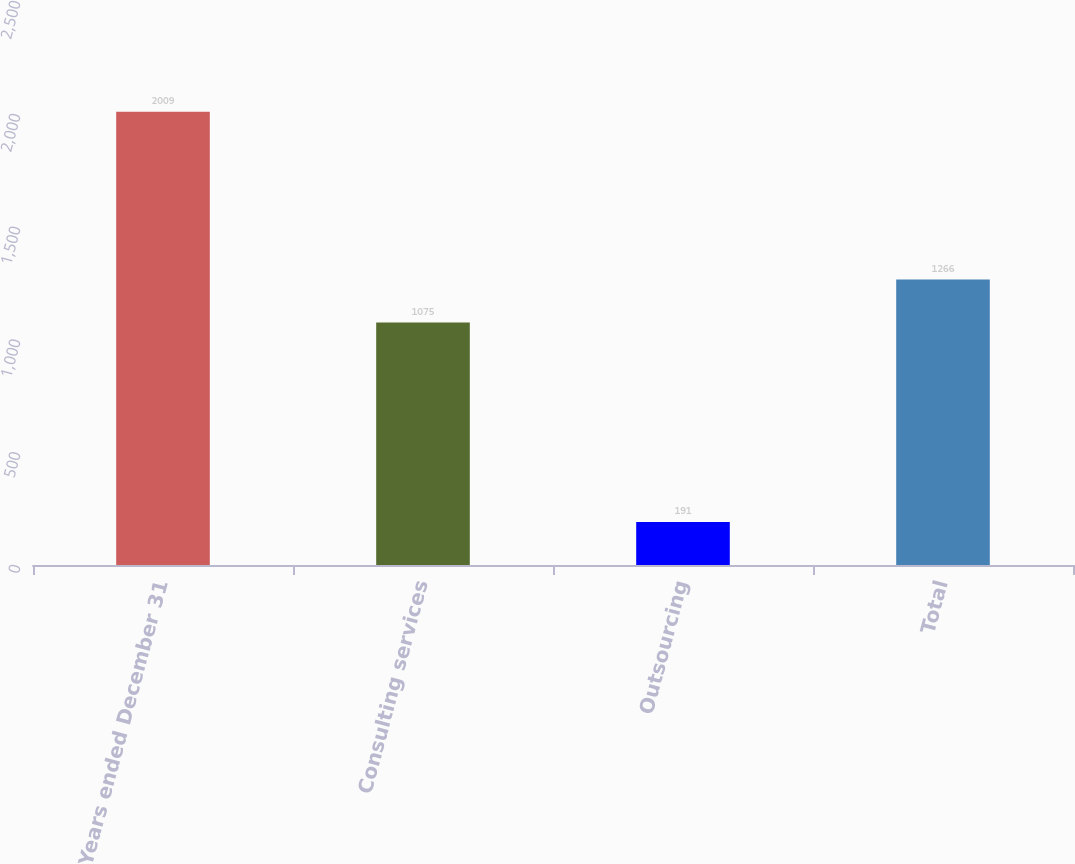Convert chart to OTSL. <chart><loc_0><loc_0><loc_500><loc_500><bar_chart><fcel>Years ended December 31<fcel>Consulting services<fcel>Outsourcing<fcel>Total<nl><fcel>2009<fcel>1075<fcel>191<fcel>1266<nl></chart> 